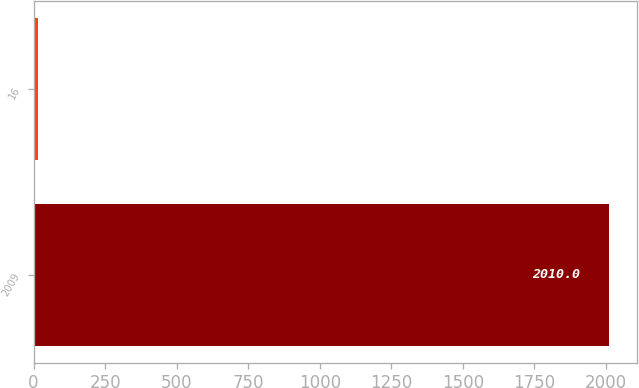Convert chart to OTSL. <chart><loc_0><loc_0><loc_500><loc_500><bar_chart><fcel>2009<fcel>16<nl><fcel>2010<fcel>15<nl></chart> 